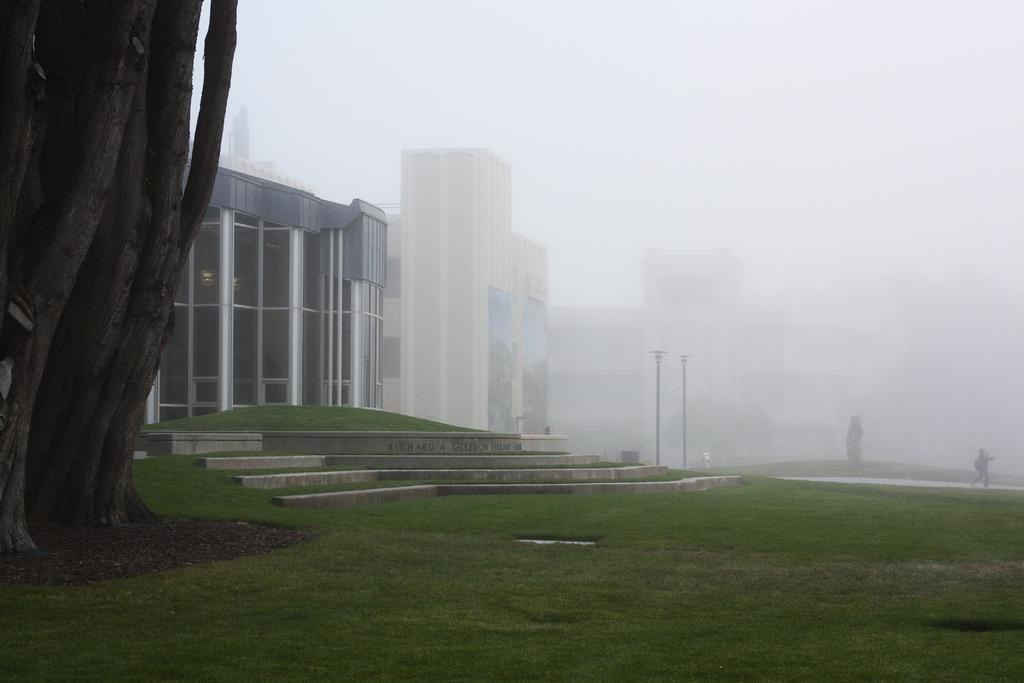In one or two sentences, can you explain what this image depicts? In the picture there is a building and beside the building,total area is covered with dark fog and there is a grass and a big tree in front of the building. 